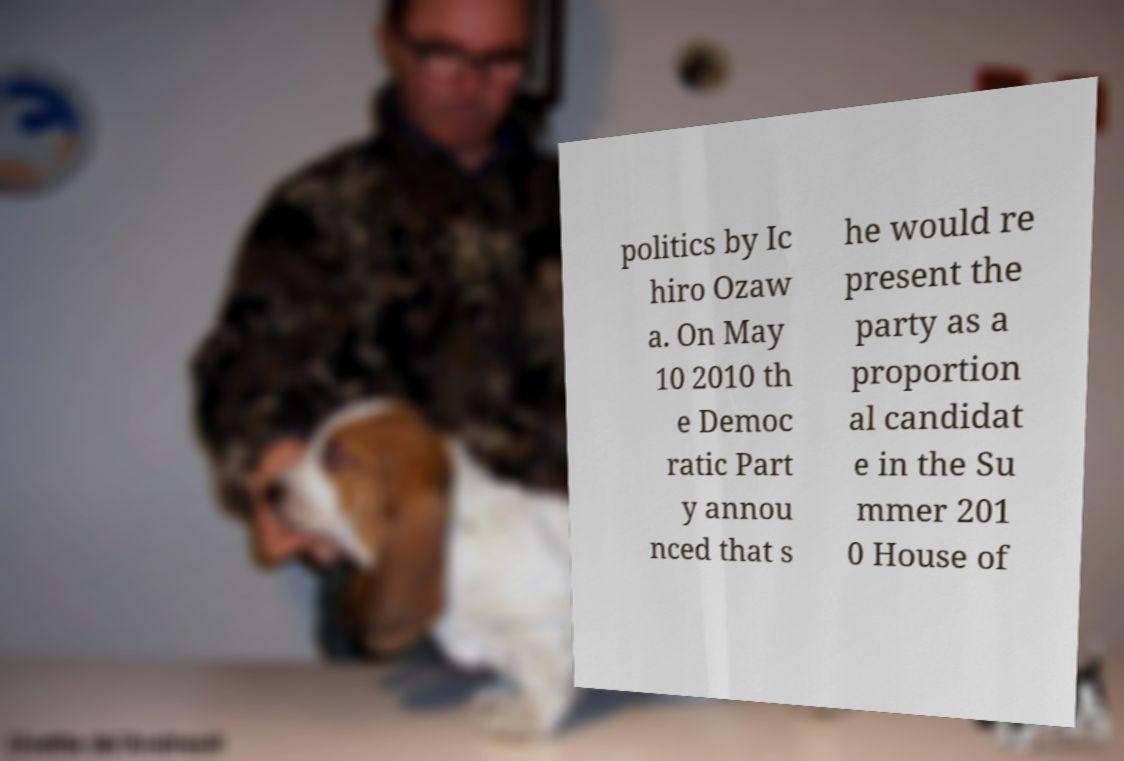For documentation purposes, I need the text within this image transcribed. Could you provide that? politics by Ic hiro Ozaw a. On May 10 2010 th e Democ ratic Part y annou nced that s he would re present the party as a proportion al candidat e in the Su mmer 201 0 House of 